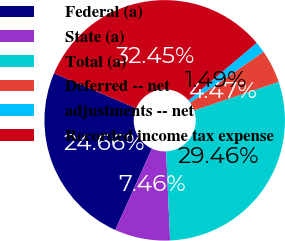<chart> <loc_0><loc_0><loc_500><loc_500><pie_chart><fcel>Federal (a)<fcel>State (a)<fcel>Total (a)<fcel>Deferred -- net<fcel>adjustments -- net<fcel>Recorded income tax expense<nl><fcel>24.66%<fcel>7.46%<fcel>29.46%<fcel>4.47%<fcel>1.49%<fcel>32.45%<nl></chart> 